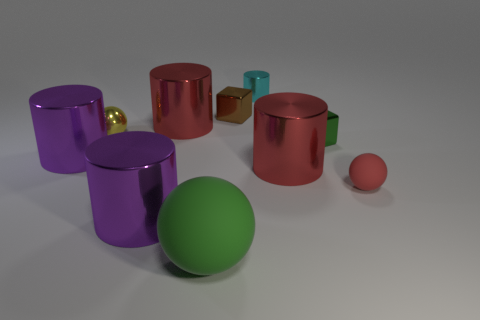Subtract all small cyan metallic cylinders. How many cylinders are left? 4 Subtract all cyan cylinders. How many cylinders are left? 4 Subtract all yellow cylinders. Subtract all yellow blocks. How many cylinders are left? 5 Subtract all cubes. How many objects are left? 8 Add 6 big purple metallic cylinders. How many big purple metallic cylinders are left? 8 Add 8 big green cylinders. How many big green cylinders exist? 8 Subtract 0 yellow cubes. How many objects are left? 10 Subtract all green matte spheres. Subtract all green matte things. How many objects are left? 8 